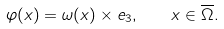Convert formula to latex. <formula><loc_0><loc_0><loc_500><loc_500>\varphi ( x ) = \omega ( x ) \times e _ { 3 } , \quad x \in \overline { \Omega } .</formula> 